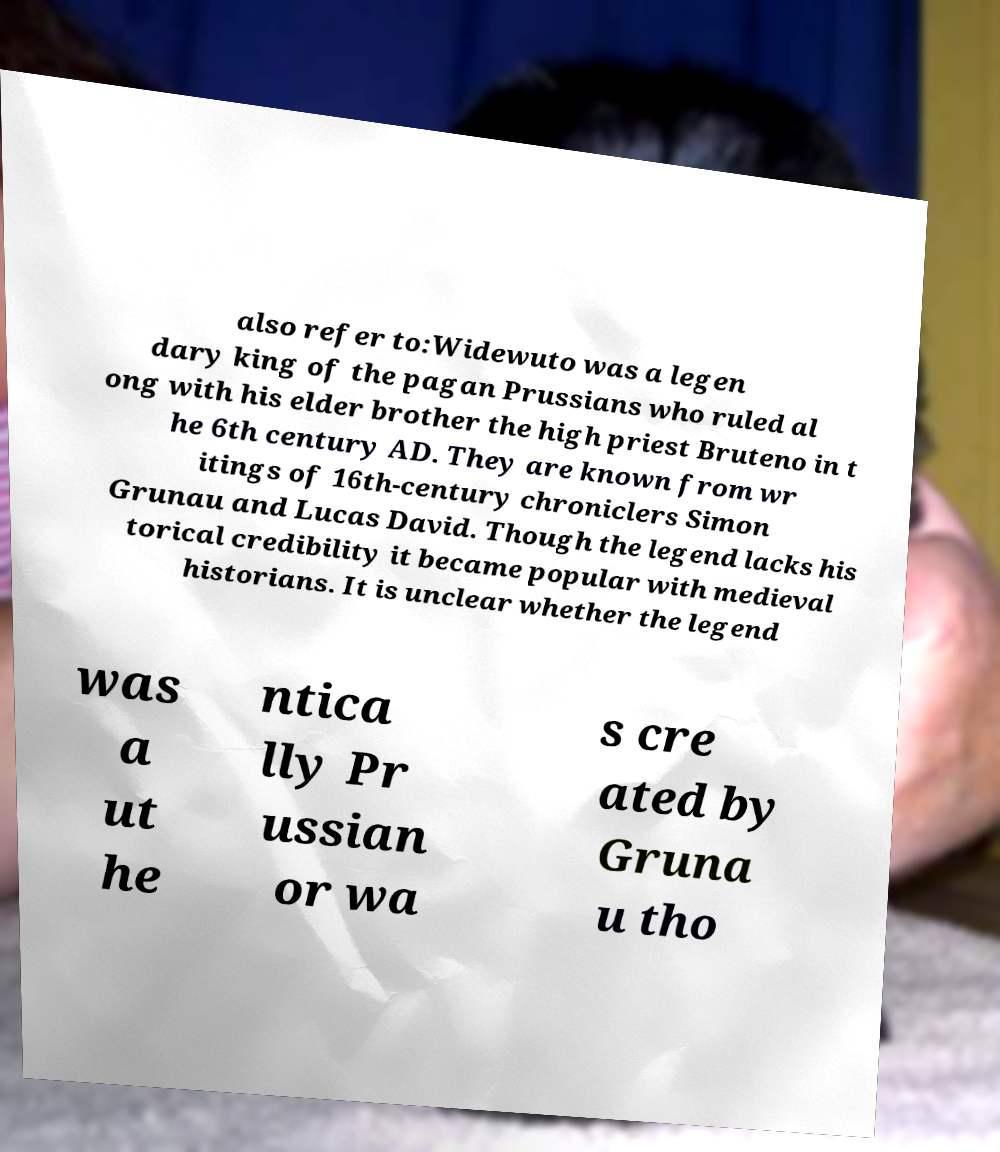I need the written content from this picture converted into text. Can you do that? also refer to:Widewuto was a legen dary king of the pagan Prussians who ruled al ong with his elder brother the high priest Bruteno in t he 6th century AD. They are known from wr itings of 16th-century chroniclers Simon Grunau and Lucas David. Though the legend lacks his torical credibility it became popular with medieval historians. It is unclear whether the legend was a ut he ntica lly Pr ussian or wa s cre ated by Gruna u tho 